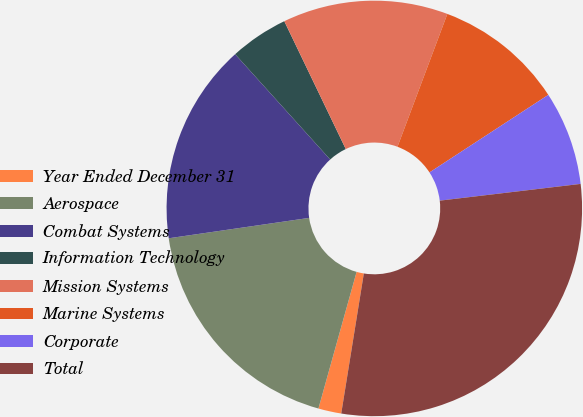Convert chart to OTSL. <chart><loc_0><loc_0><loc_500><loc_500><pie_chart><fcel>Year Ended December 31<fcel>Aerospace<fcel>Combat Systems<fcel>Information Technology<fcel>Mission Systems<fcel>Marine Systems<fcel>Corporate<fcel>Total<nl><fcel>1.79%<fcel>18.37%<fcel>15.61%<fcel>4.55%<fcel>12.85%<fcel>10.08%<fcel>7.32%<fcel>29.43%<nl></chart> 